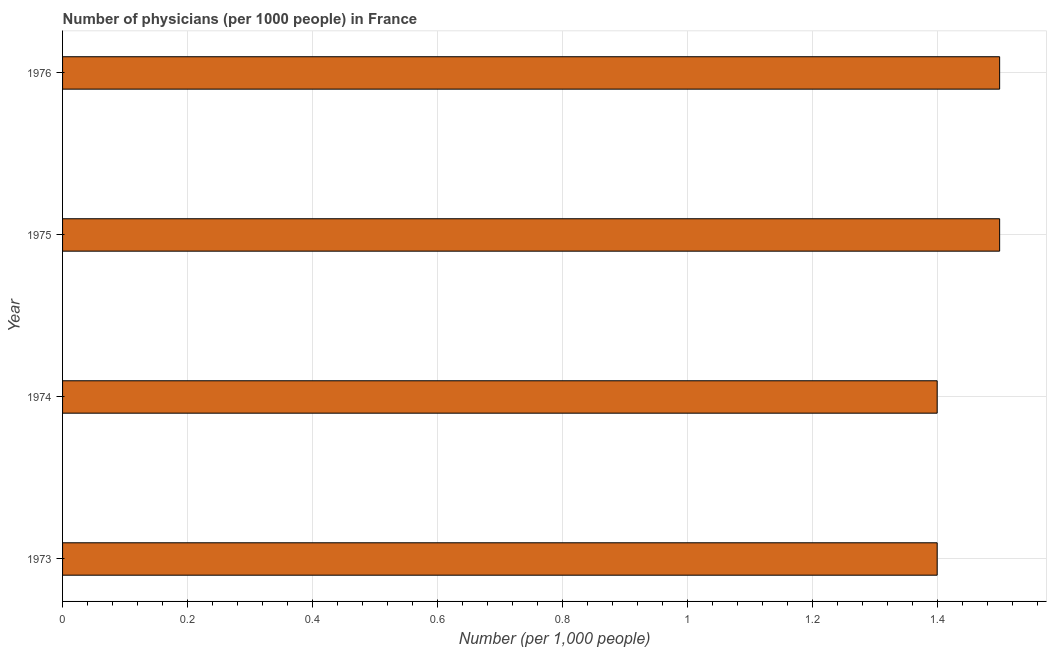Does the graph contain any zero values?
Ensure brevity in your answer.  No. Does the graph contain grids?
Give a very brief answer. Yes. What is the title of the graph?
Give a very brief answer. Number of physicians (per 1000 people) in France. What is the label or title of the X-axis?
Your response must be concise. Number (per 1,0 people). What is the number of physicians in 1976?
Provide a short and direct response. 1.5. Across all years, what is the maximum number of physicians?
Your answer should be compact. 1.5. Across all years, what is the minimum number of physicians?
Provide a succinct answer. 1.4. In which year was the number of physicians maximum?
Provide a short and direct response. 1975. In which year was the number of physicians minimum?
Make the answer very short. 1973. What is the average number of physicians per year?
Your answer should be compact. 1.45. What is the median number of physicians?
Offer a very short reply. 1.45. In how many years, is the number of physicians greater than 0.36 ?
Your answer should be compact. 4. What is the ratio of the number of physicians in 1973 to that in 1975?
Keep it short and to the point. 0.93. Is the number of physicians in 1973 less than that in 1974?
Ensure brevity in your answer.  No. Is the difference between the number of physicians in 1975 and 1976 greater than the difference between any two years?
Keep it short and to the point. No. How many bars are there?
Ensure brevity in your answer.  4. How many years are there in the graph?
Keep it short and to the point. 4. Are the values on the major ticks of X-axis written in scientific E-notation?
Your answer should be compact. No. What is the Number (per 1,000 people) of 1973?
Ensure brevity in your answer.  1.4. What is the Number (per 1,000 people) in 1975?
Give a very brief answer. 1.5. What is the Number (per 1,000 people) of 1976?
Your answer should be compact. 1.5. What is the difference between the Number (per 1,000 people) in 1973 and 1975?
Ensure brevity in your answer.  -0.1. What is the ratio of the Number (per 1,000 people) in 1973 to that in 1975?
Your answer should be very brief. 0.93. What is the ratio of the Number (per 1,000 people) in 1973 to that in 1976?
Your answer should be very brief. 0.93. What is the ratio of the Number (per 1,000 people) in 1974 to that in 1975?
Keep it short and to the point. 0.93. What is the ratio of the Number (per 1,000 people) in 1974 to that in 1976?
Provide a short and direct response. 0.93. What is the ratio of the Number (per 1,000 people) in 1975 to that in 1976?
Keep it short and to the point. 1. 